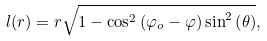<formula> <loc_0><loc_0><loc_500><loc_500>l ( r ) = r \sqrt { 1 - \cos ^ { 2 } \left ( \varphi _ { o } - \varphi \right ) \sin ^ { 2 } \left ( \theta \right ) } ,</formula> 